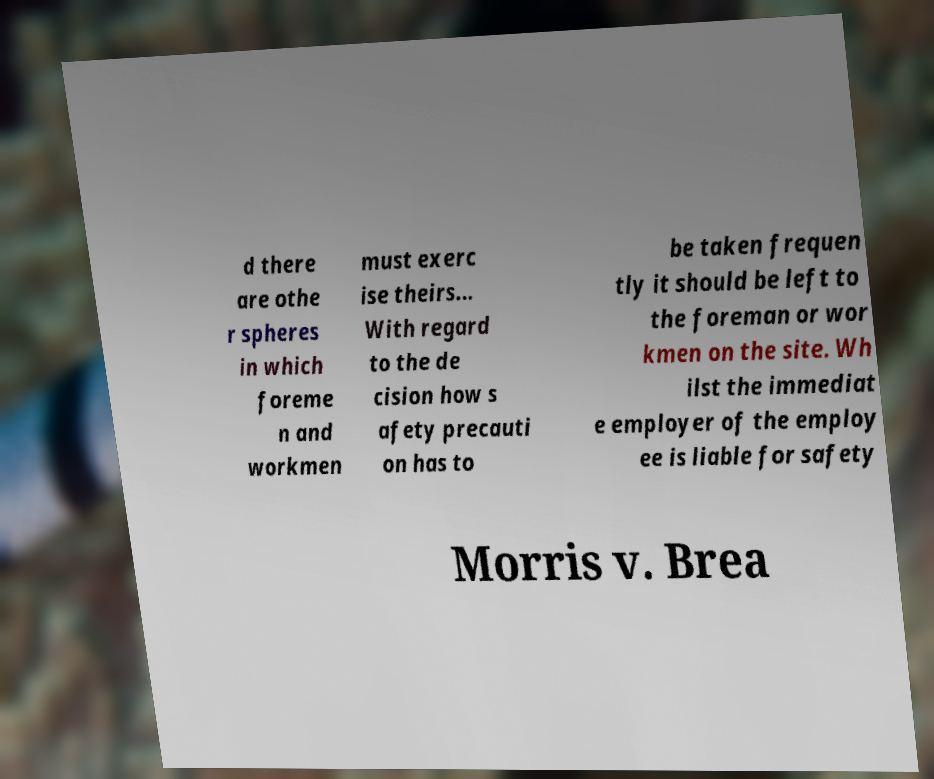Could you extract and type out the text from this image? d there are othe r spheres in which foreme n and workmen must exerc ise theirs... With regard to the de cision how s afety precauti on has to be taken frequen tly it should be left to the foreman or wor kmen on the site. Wh ilst the immediat e employer of the employ ee is liable for safety Morris v. Brea 